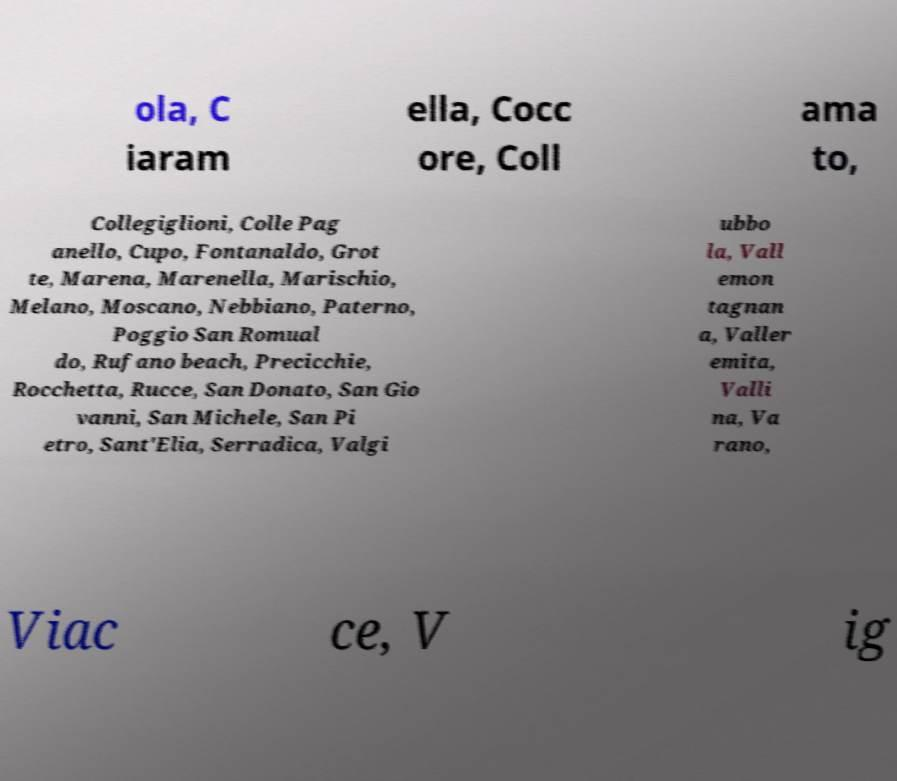Can you read and provide the text displayed in the image?This photo seems to have some interesting text. Can you extract and type it out for me? ola, C iaram ella, Cocc ore, Coll ama to, Collegiglioni, Colle Pag anello, Cupo, Fontanaldo, Grot te, Marena, Marenella, Marischio, Melano, Moscano, Nebbiano, Paterno, Poggio San Romual do, Rufano beach, Precicchie, Rocchetta, Rucce, San Donato, San Gio vanni, San Michele, San Pi etro, Sant'Elia, Serradica, Valgi ubbo la, Vall emon tagnan a, Valler emita, Valli na, Va rano, Viac ce, V ig 